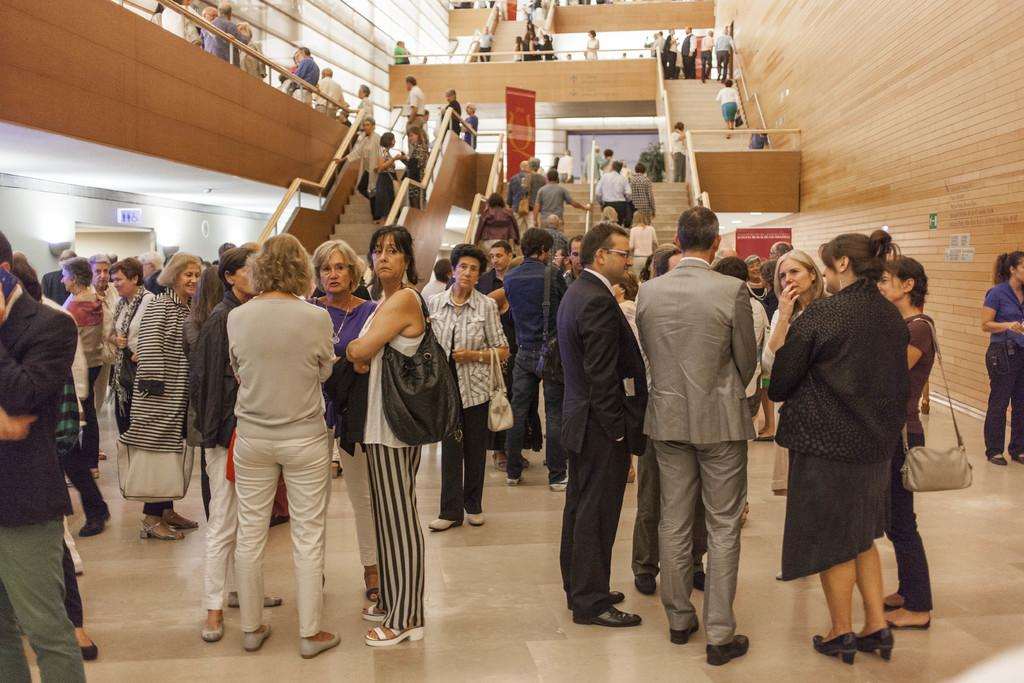What can be seen in the foreground of the image? There are people standing in the foreground of the image. What is located in the middle of the image? There is a stair in the middle of the image. What is on the right side of the image? There is a wall on the right side of the image. What type of food is being served at the meeting in the image? There is no meeting or food present in the image; it only features people, a stair, and a wall. 